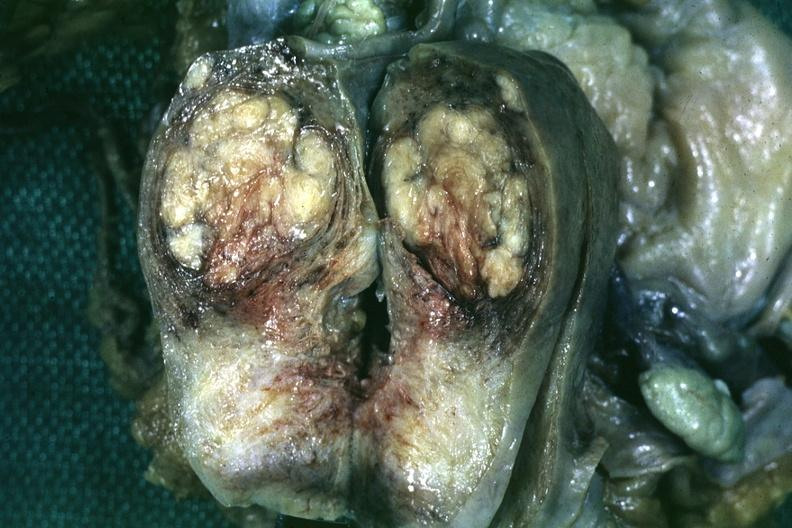s leiomyoma present?
Answer the question using a single word or phrase. Yes 